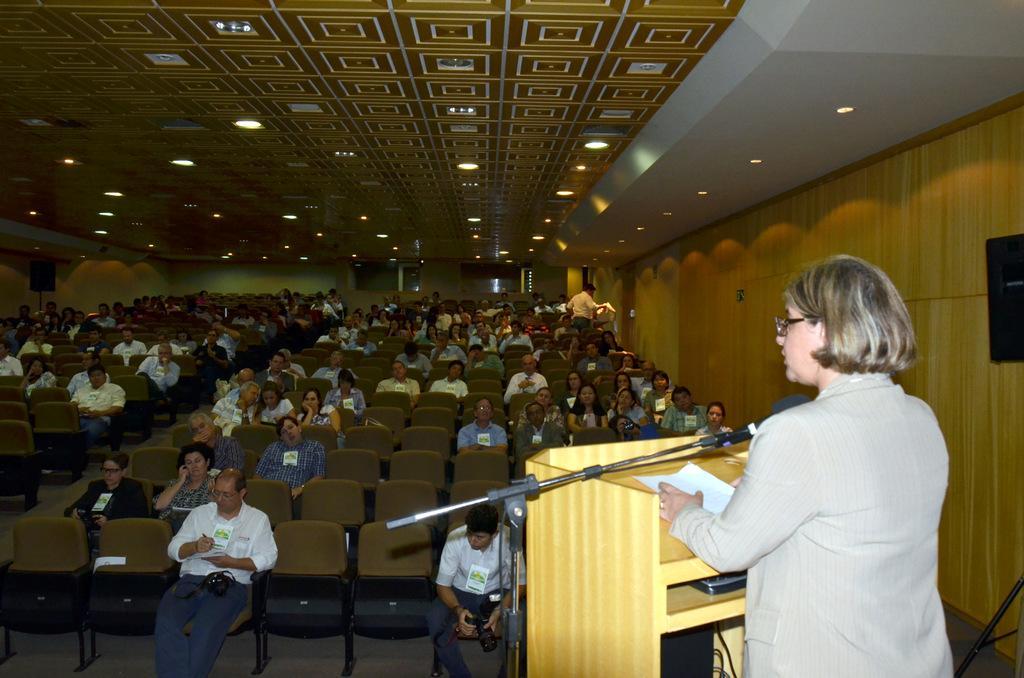In one or two sentences, can you explain what this image depicts? This picture is clicked in the concert room. Here, we see many people are sitting on the chairs. The man in the white shirt is standing. In the right bottom of the picture, the woman in grey blazer is standing. In front of her, we see a podium on which paper is placed. We even see a microphone. She might be talking on the microphone. On the right side, we see a wall. At the top of the picture, we see the ceiling of the hall. 